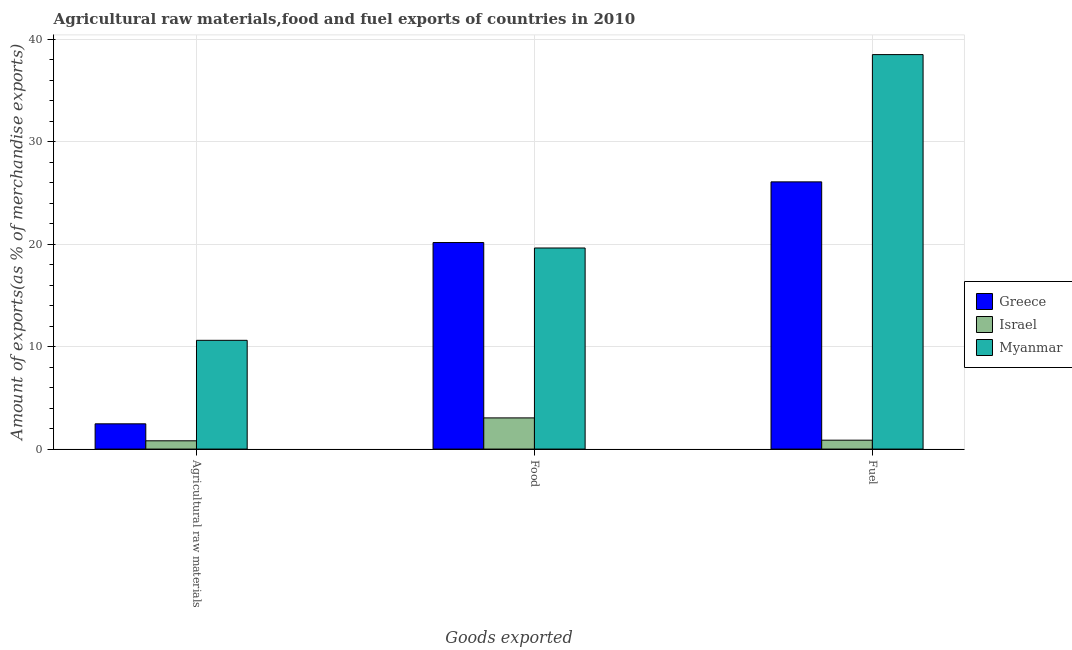Are the number of bars per tick equal to the number of legend labels?
Your answer should be compact. Yes. Are the number of bars on each tick of the X-axis equal?
Make the answer very short. Yes. How many bars are there on the 1st tick from the left?
Give a very brief answer. 3. How many bars are there on the 3rd tick from the right?
Offer a very short reply. 3. What is the label of the 3rd group of bars from the left?
Your response must be concise. Fuel. What is the percentage of food exports in Israel?
Offer a very short reply. 3.04. Across all countries, what is the maximum percentage of raw materials exports?
Keep it short and to the point. 10.61. Across all countries, what is the minimum percentage of raw materials exports?
Provide a succinct answer. 0.81. In which country was the percentage of raw materials exports maximum?
Offer a terse response. Myanmar. What is the total percentage of food exports in the graph?
Your response must be concise. 42.83. What is the difference between the percentage of fuel exports in Israel and that in Greece?
Give a very brief answer. -25.21. What is the difference between the percentage of raw materials exports in Israel and the percentage of fuel exports in Myanmar?
Ensure brevity in your answer.  -37.7. What is the average percentage of food exports per country?
Your answer should be very brief. 14.28. What is the difference between the percentage of fuel exports and percentage of food exports in Greece?
Ensure brevity in your answer.  5.92. What is the ratio of the percentage of fuel exports in Israel to that in Greece?
Keep it short and to the point. 0.03. What is the difference between the highest and the second highest percentage of food exports?
Provide a succinct answer. 0.53. What is the difference between the highest and the lowest percentage of fuel exports?
Provide a succinct answer. 37.64. What does the 3rd bar from the left in Fuel represents?
Offer a very short reply. Myanmar. What does the 1st bar from the right in Fuel represents?
Keep it short and to the point. Myanmar. How many bars are there?
Your response must be concise. 9. Are all the bars in the graph horizontal?
Make the answer very short. No. What is the difference between two consecutive major ticks on the Y-axis?
Ensure brevity in your answer.  10. Are the values on the major ticks of Y-axis written in scientific E-notation?
Give a very brief answer. No. How many legend labels are there?
Your answer should be very brief. 3. How are the legend labels stacked?
Give a very brief answer. Vertical. What is the title of the graph?
Keep it short and to the point. Agricultural raw materials,food and fuel exports of countries in 2010. What is the label or title of the X-axis?
Offer a terse response. Goods exported. What is the label or title of the Y-axis?
Provide a short and direct response. Amount of exports(as % of merchandise exports). What is the Amount of exports(as % of merchandise exports) in Greece in Agricultural raw materials?
Ensure brevity in your answer.  2.47. What is the Amount of exports(as % of merchandise exports) in Israel in Agricultural raw materials?
Offer a very short reply. 0.81. What is the Amount of exports(as % of merchandise exports) in Myanmar in Agricultural raw materials?
Make the answer very short. 10.61. What is the Amount of exports(as % of merchandise exports) of Greece in Food?
Provide a succinct answer. 20.16. What is the Amount of exports(as % of merchandise exports) of Israel in Food?
Keep it short and to the point. 3.04. What is the Amount of exports(as % of merchandise exports) in Myanmar in Food?
Your answer should be very brief. 19.63. What is the Amount of exports(as % of merchandise exports) in Greece in Fuel?
Provide a succinct answer. 26.08. What is the Amount of exports(as % of merchandise exports) in Israel in Fuel?
Provide a succinct answer. 0.87. What is the Amount of exports(as % of merchandise exports) in Myanmar in Fuel?
Offer a terse response. 38.5. Across all Goods exported, what is the maximum Amount of exports(as % of merchandise exports) in Greece?
Your answer should be compact. 26.08. Across all Goods exported, what is the maximum Amount of exports(as % of merchandise exports) in Israel?
Your response must be concise. 3.04. Across all Goods exported, what is the maximum Amount of exports(as % of merchandise exports) in Myanmar?
Your answer should be compact. 38.5. Across all Goods exported, what is the minimum Amount of exports(as % of merchandise exports) of Greece?
Provide a succinct answer. 2.47. Across all Goods exported, what is the minimum Amount of exports(as % of merchandise exports) in Israel?
Your answer should be very brief. 0.81. Across all Goods exported, what is the minimum Amount of exports(as % of merchandise exports) of Myanmar?
Provide a succinct answer. 10.61. What is the total Amount of exports(as % of merchandise exports) in Greece in the graph?
Your answer should be very brief. 48.71. What is the total Amount of exports(as % of merchandise exports) in Israel in the graph?
Offer a very short reply. 4.72. What is the total Amount of exports(as % of merchandise exports) of Myanmar in the graph?
Your response must be concise. 68.75. What is the difference between the Amount of exports(as % of merchandise exports) of Greece in Agricultural raw materials and that in Food?
Make the answer very short. -17.69. What is the difference between the Amount of exports(as % of merchandise exports) of Israel in Agricultural raw materials and that in Food?
Make the answer very short. -2.24. What is the difference between the Amount of exports(as % of merchandise exports) in Myanmar in Agricultural raw materials and that in Food?
Offer a very short reply. -9.01. What is the difference between the Amount of exports(as % of merchandise exports) of Greece in Agricultural raw materials and that in Fuel?
Your answer should be very brief. -23.62. What is the difference between the Amount of exports(as % of merchandise exports) in Israel in Agricultural raw materials and that in Fuel?
Provide a succinct answer. -0.06. What is the difference between the Amount of exports(as % of merchandise exports) of Myanmar in Agricultural raw materials and that in Fuel?
Make the answer very short. -27.89. What is the difference between the Amount of exports(as % of merchandise exports) of Greece in Food and that in Fuel?
Keep it short and to the point. -5.92. What is the difference between the Amount of exports(as % of merchandise exports) of Israel in Food and that in Fuel?
Make the answer very short. 2.18. What is the difference between the Amount of exports(as % of merchandise exports) in Myanmar in Food and that in Fuel?
Offer a very short reply. -18.88. What is the difference between the Amount of exports(as % of merchandise exports) in Greece in Agricultural raw materials and the Amount of exports(as % of merchandise exports) in Israel in Food?
Offer a very short reply. -0.58. What is the difference between the Amount of exports(as % of merchandise exports) of Greece in Agricultural raw materials and the Amount of exports(as % of merchandise exports) of Myanmar in Food?
Your response must be concise. -17.16. What is the difference between the Amount of exports(as % of merchandise exports) of Israel in Agricultural raw materials and the Amount of exports(as % of merchandise exports) of Myanmar in Food?
Your answer should be very brief. -18.82. What is the difference between the Amount of exports(as % of merchandise exports) in Greece in Agricultural raw materials and the Amount of exports(as % of merchandise exports) in Israel in Fuel?
Provide a short and direct response. 1.6. What is the difference between the Amount of exports(as % of merchandise exports) in Greece in Agricultural raw materials and the Amount of exports(as % of merchandise exports) in Myanmar in Fuel?
Offer a very short reply. -36.04. What is the difference between the Amount of exports(as % of merchandise exports) in Israel in Agricultural raw materials and the Amount of exports(as % of merchandise exports) in Myanmar in Fuel?
Offer a very short reply. -37.7. What is the difference between the Amount of exports(as % of merchandise exports) in Greece in Food and the Amount of exports(as % of merchandise exports) in Israel in Fuel?
Ensure brevity in your answer.  19.29. What is the difference between the Amount of exports(as % of merchandise exports) in Greece in Food and the Amount of exports(as % of merchandise exports) in Myanmar in Fuel?
Provide a short and direct response. -18.34. What is the difference between the Amount of exports(as % of merchandise exports) of Israel in Food and the Amount of exports(as % of merchandise exports) of Myanmar in Fuel?
Provide a succinct answer. -35.46. What is the average Amount of exports(as % of merchandise exports) in Greece per Goods exported?
Ensure brevity in your answer.  16.24. What is the average Amount of exports(as % of merchandise exports) of Israel per Goods exported?
Keep it short and to the point. 1.57. What is the average Amount of exports(as % of merchandise exports) of Myanmar per Goods exported?
Give a very brief answer. 22.92. What is the difference between the Amount of exports(as % of merchandise exports) of Greece and Amount of exports(as % of merchandise exports) of Israel in Agricultural raw materials?
Offer a very short reply. 1.66. What is the difference between the Amount of exports(as % of merchandise exports) of Greece and Amount of exports(as % of merchandise exports) of Myanmar in Agricultural raw materials?
Offer a terse response. -8.15. What is the difference between the Amount of exports(as % of merchandise exports) of Israel and Amount of exports(as % of merchandise exports) of Myanmar in Agricultural raw materials?
Ensure brevity in your answer.  -9.81. What is the difference between the Amount of exports(as % of merchandise exports) in Greece and Amount of exports(as % of merchandise exports) in Israel in Food?
Offer a very short reply. 17.12. What is the difference between the Amount of exports(as % of merchandise exports) in Greece and Amount of exports(as % of merchandise exports) in Myanmar in Food?
Provide a short and direct response. 0.53. What is the difference between the Amount of exports(as % of merchandise exports) of Israel and Amount of exports(as % of merchandise exports) of Myanmar in Food?
Provide a succinct answer. -16.58. What is the difference between the Amount of exports(as % of merchandise exports) of Greece and Amount of exports(as % of merchandise exports) of Israel in Fuel?
Offer a very short reply. 25.21. What is the difference between the Amount of exports(as % of merchandise exports) in Greece and Amount of exports(as % of merchandise exports) in Myanmar in Fuel?
Provide a succinct answer. -12.42. What is the difference between the Amount of exports(as % of merchandise exports) in Israel and Amount of exports(as % of merchandise exports) in Myanmar in Fuel?
Keep it short and to the point. -37.64. What is the ratio of the Amount of exports(as % of merchandise exports) of Greece in Agricultural raw materials to that in Food?
Keep it short and to the point. 0.12. What is the ratio of the Amount of exports(as % of merchandise exports) of Israel in Agricultural raw materials to that in Food?
Give a very brief answer. 0.27. What is the ratio of the Amount of exports(as % of merchandise exports) in Myanmar in Agricultural raw materials to that in Food?
Provide a succinct answer. 0.54. What is the ratio of the Amount of exports(as % of merchandise exports) in Greece in Agricultural raw materials to that in Fuel?
Ensure brevity in your answer.  0.09. What is the ratio of the Amount of exports(as % of merchandise exports) of Myanmar in Agricultural raw materials to that in Fuel?
Give a very brief answer. 0.28. What is the ratio of the Amount of exports(as % of merchandise exports) of Greece in Food to that in Fuel?
Your answer should be very brief. 0.77. What is the ratio of the Amount of exports(as % of merchandise exports) of Israel in Food to that in Fuel?
Offer a very short reply. 3.51. What is the ratio of the Amount of exports(as % of merchandise exports) of Myanmar in Food to that in Fuel?
Offer a terse response. 0.51. What is the difference between the highest and the second highest Amount of exports(as % of merchandise exports) in Greece?
Your response must be concise. 5.92. What is the difference between the highest and the second highest Amount of exports(as % of merchandise exports) in Israel?
Give a very brief answer. 2.18. What is the difference between the highest and the second highest Amount of exports(as % of merchandise exports) in Myanmar?
Provide a short and direct response. 18.88. What is the difference between the highest and the lowest Amount of exports(as % of merchandise exports) in Greece?
Your answer should be very brief. 23.62. What is the difference between the highest and the lowest Amount of exports(as % of merchandise exports) of Israel?
Your answer should be very brief. 2.24. What is the difference between the highest and the lowest Amount of exports(as % of merchandise exports) of Myanmar?
Offer a terse response. 27.89. 